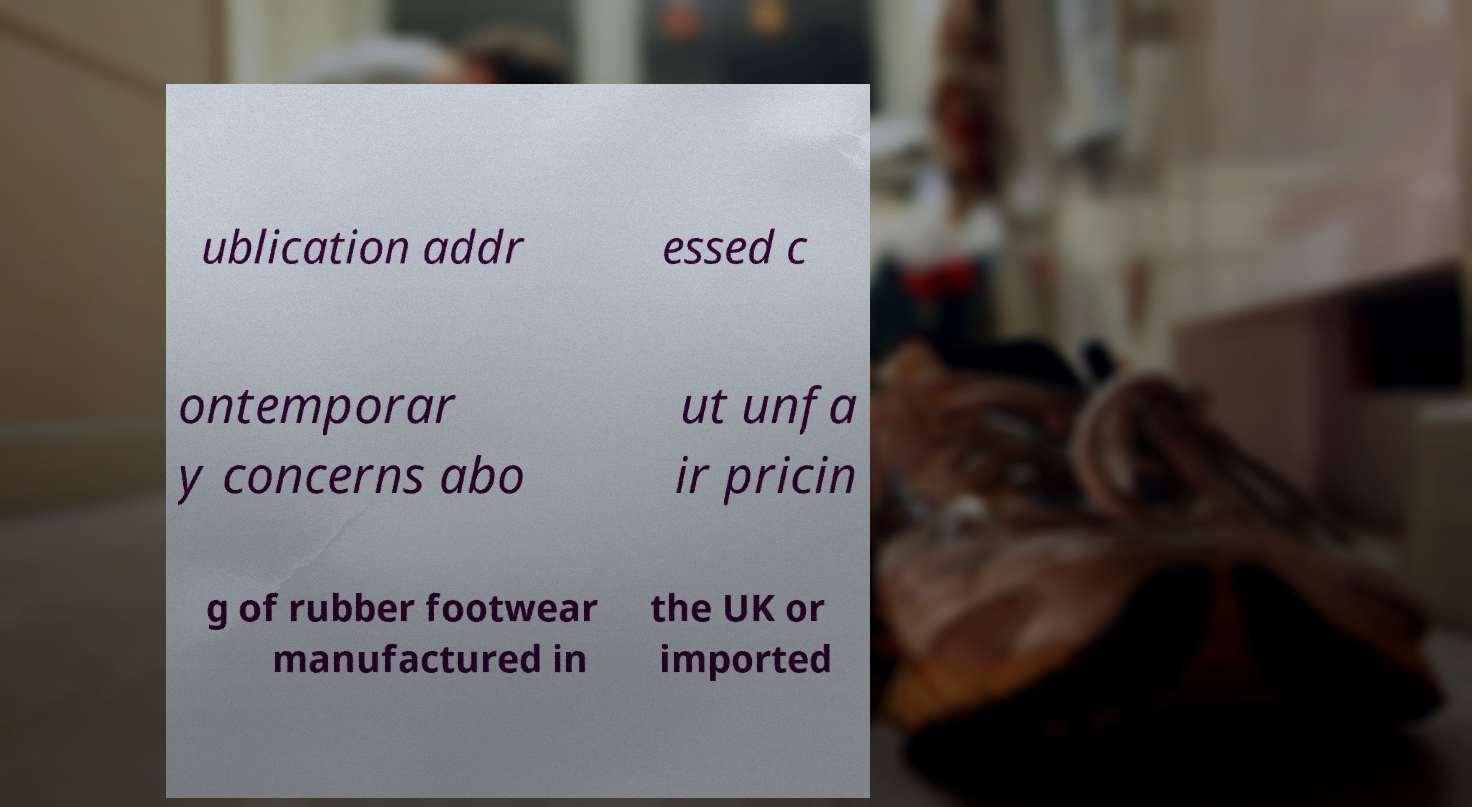Please identify and transcribe the text found in this image. ublication addr essed c ontemporar y concerns abo ut unfa ir pricin g of rubber footwear manufactured in the UK or imported 